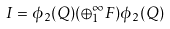Convert formula to latex. <formula><loc_0><loc_0><loc_500><loc_500>I = \phi _ { 2 } ( Q ) ( \oplus _ { 1 } ^ { \infty } F ) \phi _ { 2 } ( Q )</formula> 